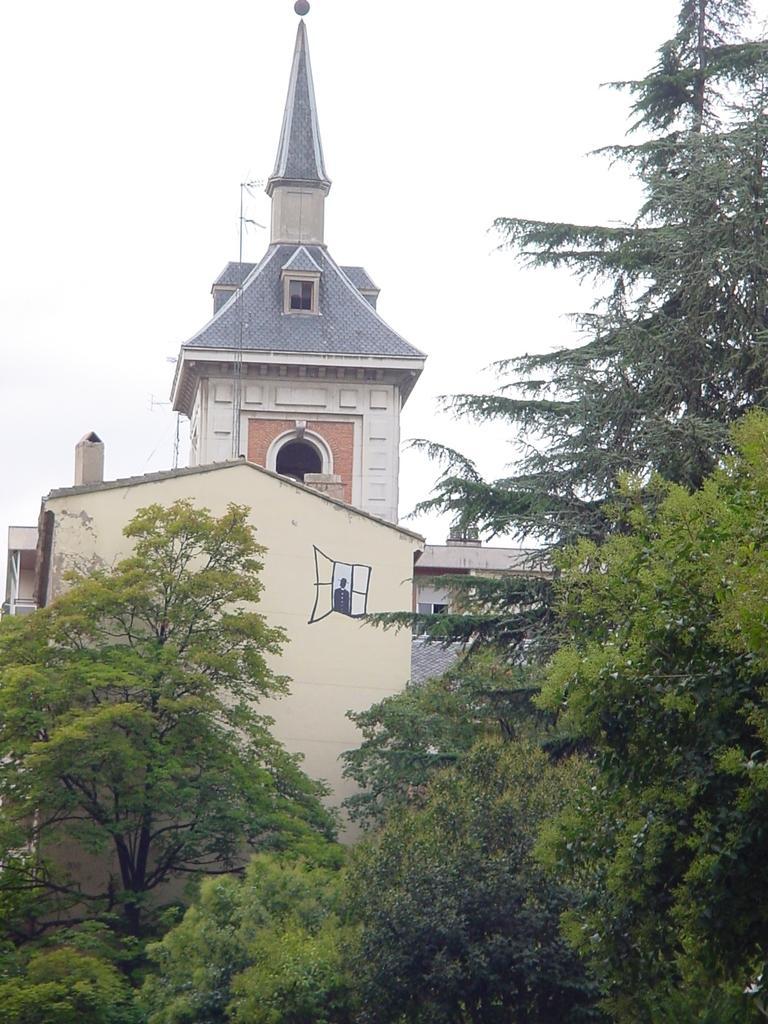Please provide a concise description of this image. In the foreground of the picture there are trees. In the center of the picture there is a cathedral. Sky is cloudy. 